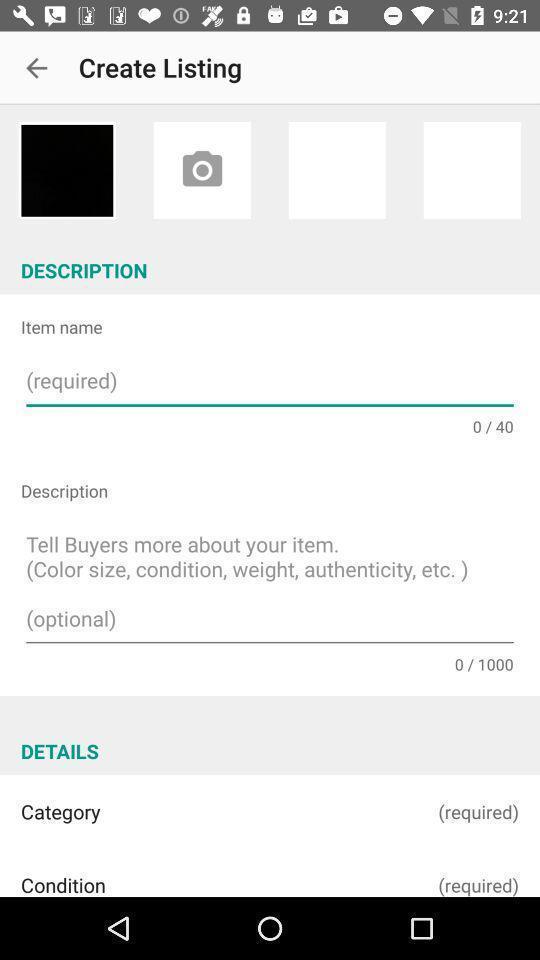Explain what's happening in this screen capture. Screen showing create listing. 